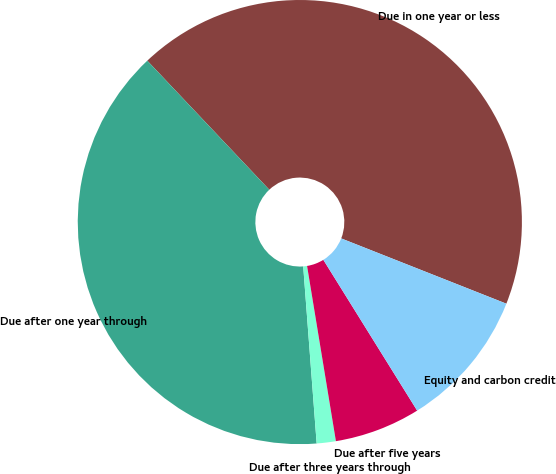<chart> <loc_0><loc_0><loc_500><loc_500><pie_chart><fcel>Due in one year or less<fcel>Due after one year through<fcel>Due after three years through<fcel>Due after five years<fcel>Equity and carbon credit<nl><fcel>43.04%<fcel>39.15%<fcel>1.39%<fcel>6.26%<fcel>10.15%<nl></chart> 